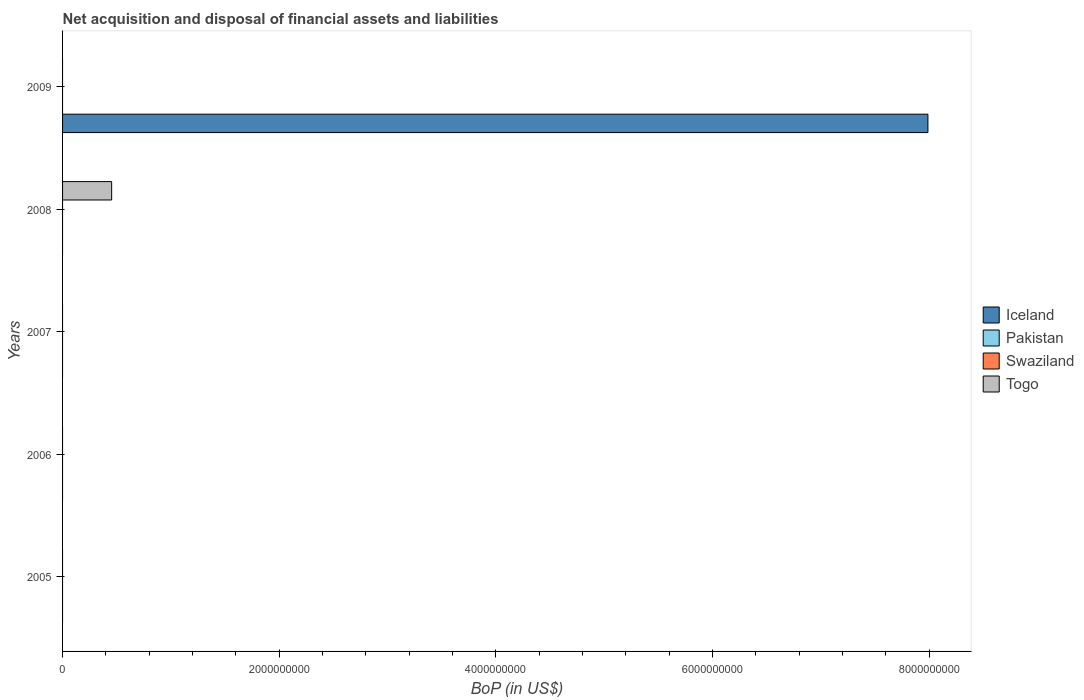Are the number of bars per tick equal to the number of legend labels?
Ensure brevity in your answer.  No. Are the number of bars on each tick of the Y-axis equal?
Provide a succinct answer. No. How many bars are there on the 3rd tick from the top?
Your response must be concise. 0. In how many cases, is the number of bars for a given year not equal to the number of legend labels?
Keep it short and to the point. 5. Across all years, what is the maximum Balance of Payments in Togo?
Your response must be concise. 4.53e+08. What is the total Balance of Payments in Pakistan in the graph?
Offer a terse response. 0. What is the average Balance of Payments in Iceland per year?
Keep it short and to the point. 1.60e+09. What is the difference between the highest and the lowest Balance of Payments in Togo?
Provide a short and direct response. 4.53e+08. In how many years, is the Balance of Payments in Pakistan greater than the average Balance of Payments in Pakistan taken over all years?
Offer a terse response. 0. Is it the case that in every year, the sum of the Balance of Payments in Pakistan and Balance of Payments in Iceland is greater than the sum of Balance of Payments in Swaziland and Balance of Payments in Togo?
Make the answer very short. No. Is it the case that in every year, the sum of the Balance of Payments in Iceland and Balance of Payments in Pakistan is greater than the Balance of Payments in Togo?
Make the answer very short. No. What is the difference between two consecutive major ticks on the X-axis?
Keep it short and to the point. 2.00e+09. What is the title of the graph?
Offer a very short reply. Net acquisition and disposal of financial assets and liabilities. What is the label or title of the X-axis?
Keep it short and to the point. BoP (in US$). What is the BoP (in US$) of Iceland in 2006?
Keep it short and to the point. 0. What is the BoP (in US$) of Pakistan in 2006?
Provide a succinct answer. 0. What is the BoP (in US$) of Swaziland in 2006?
Your answer should be very brief. 0. What is the BoP (in US$) of Togo in 2006?
Keep it short and to the point. 0. What is the BoP (in US$) of Pakistan in 2007?
Provide a succinct answer. 0. What is the BoP (in US$) of Swaziland in 2007?
Give a very brief answer. 0. What is the BoP (in US$) in Togo in 2007?
Provide a short and direct response. 0. What is the BoP (in US$) of Iceland in 2008?
Make the answer very short. 0. What is the BoP (in US$) of Pakistan in 2008?
Your answer should be very brief. 0. What is the BoP (in US$) in Togo in 2008?
Your answer should be compact. 4.53e+08. What is the BoP (in US$) of Iceland in 2009?
Keep it short and to the point. 7.99e+09. Across all years, what is the maximum BoP (in US$) of Iceland?
Give a very brief answer. 7.99e+09. Across all years, what is the maximum BoP (in US$) in Togo?
Offer a very short reply. 4.53e+08. Across all years, what is the minimum BoP (in US$) in Togo?
Your answer should be compact. 0. What is the total BoP (in US$) in Iceland in the graph?
Your answer should be very brief. 7.99e+09. What is the total BoP (in US$) in Pakistan in the graph?
Your answer should be very brief. 0. What is the total BoP (in US$) of Swaziland in the graph?
Your response must be concise. 0. What is the total BoP (in US$) in Togo in the graph?
Ensure brevity in your answer.  4.53e+08. What is the average BoP (in US$) in Iceland per year?
Provide a succinct answer. 1.60e+09. What is the average BoP (in US$) in Pakistan per year?
Provide a short and direct response. 0. What is the average BoP (in US$) in Togo per year?
Provide a short and direct response. 9.06e+07. What is the difference between the highest and the lowest BoP (in US$) in Iceland?
Give a very brief answer. 7.99e+09. What is the difference between the highest and the lowest BoP (in US$) in Togo?
Offer a very short reply. 4.53e+08. 